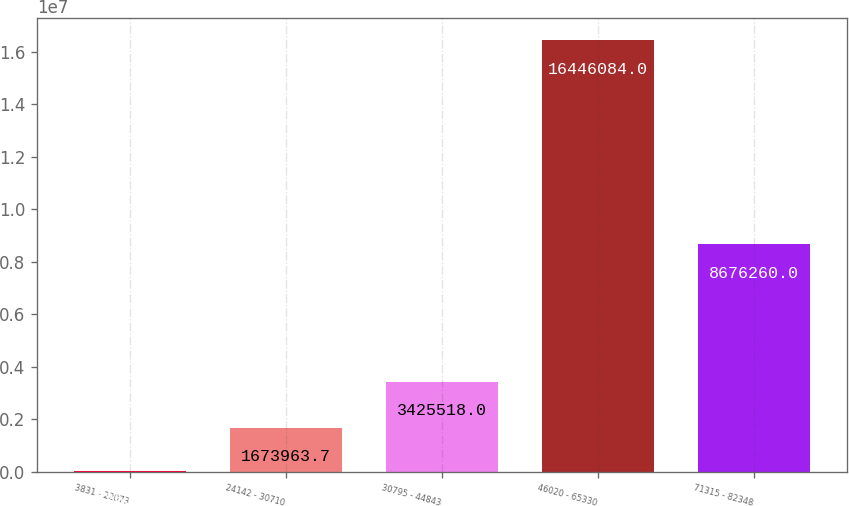<chart> <loc_0><loc_0><loc_500><loc_500><bar_chart><fcel>3831 - 22073<fcel>24142 - 30710<fcel>30795 - 44843<fcel>46020 - 65330<fcel>71315 - 82348<nl><fcel>32617<fcel>1.67396e+06<fcel>3.42552e+06<fcel>1.64461e+07<fcel>8.67626e+06<nl></chart> 